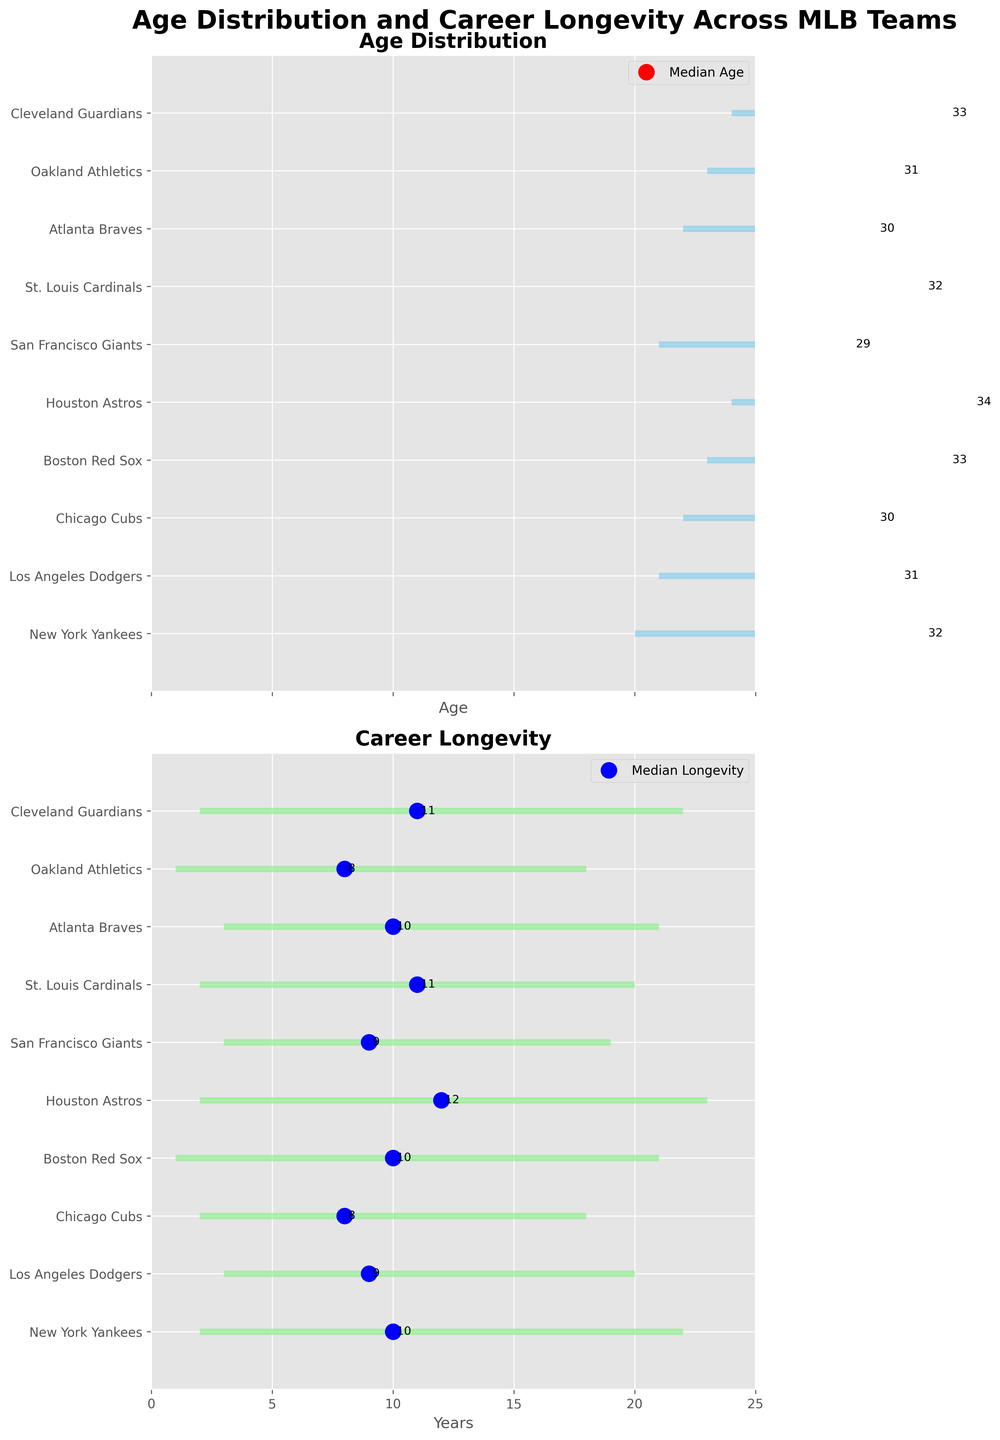Which team has the youngest minimum age? By looking at the Age Distribution plot, we identify that the New York Yankees have the youngest minimum age of 20 years.
Answer: New York Yankees What is the median career longevity for the St. Louis Cardinals? By referring to the Career Longevity section, we find that the median career longevity for the St. Louis Cardinals is 11 years, as indicated by the blue dot along the St. Louis Cardinals row.
Answer: 11 years Which team has the oldest maximum age? By checking the maximum age in the Age Distribution plot, the Houston Astros have the oldest maximum age of 44 years.
Answer: Houston Astros How many years is the median career longevity of New York Yankees less than that of Houston Astros? The Career Longevity plot shows that the median career longevity for the New York Yankees is 10 years and for the Houston Astros is 12 years, so the difference is 12 - 10 = 2 years.
Answer: 2 years Which team has the smallest range of ages? The range of ages is the difference between the maximum and minimum ages. The San Francisco Giants have the smallest range, with a maximum age of 38 and a minimum age of 21, giving a range of 17 years.
Answer: San Francisco Giants Compare the maximum career longevity between the Boston Red Sox and Cleveland Guardians. The Career Longevity plot indicates that the Boston Red Sox have a maximum career longevity of 21 years and the Cleveland Guardians have a maximum of 22 years, so the Cleveland Guardians have a higher maximum career longevity.
Answer: Cleveland Guardians What is the age range for the Atlanta Braves? The Age Distribution plot shows that the minimum age for the Atlanta Braves is 22 and the maximum age is 41, resulting in an age range of 41 - 22 = 19 years.
Answer: 19 years Which team has the highest median age, and what is it? By looking at the Age Distribution plot, the Houston Astros have the highest median age of 34 years.
Answer: Houston Astros What is the difference in maximum career longevity between the team with the lowest maximum and the team with the highest maximum? The Career Longevity plot shows the San Francisco Giants with the lowest maximum career longevity of 19 years and the Houston Astros with the highest maximum of 23 years. The difference is 23 - 19 = 4 years.
Answer: 4 years 